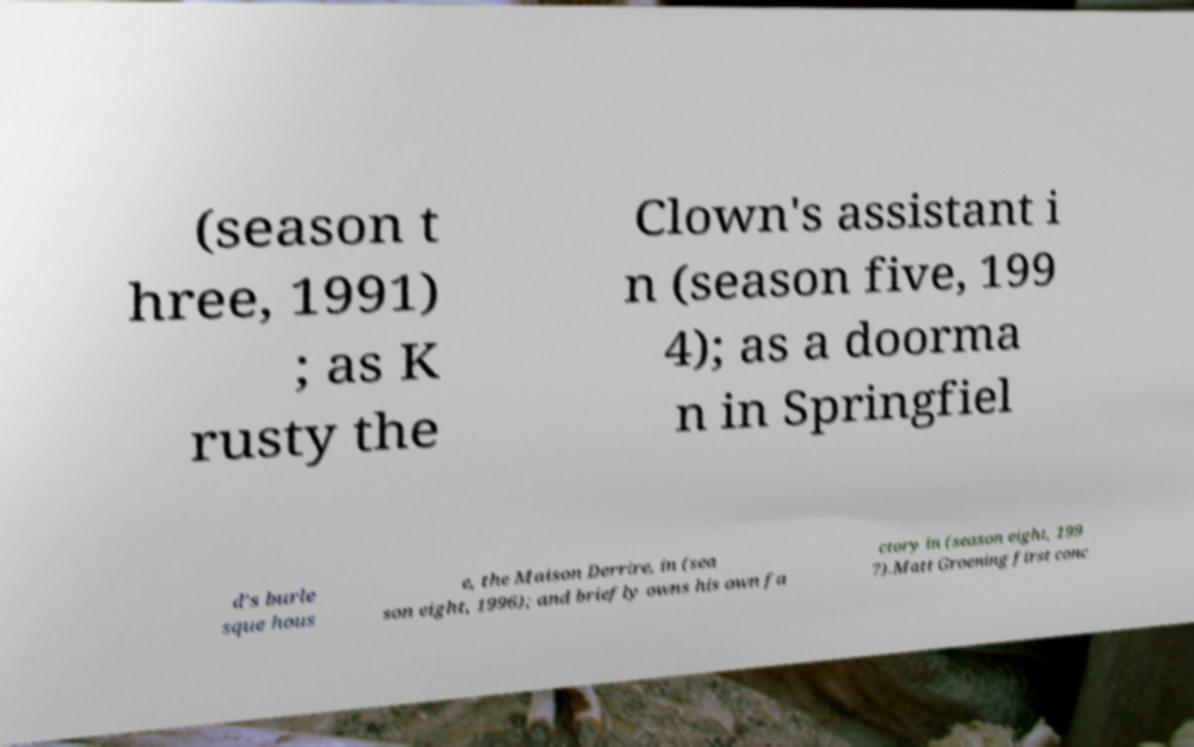Could you assist in decoding the text presented in this image and type it out clearly? (season t hree, 1991) ; as K rusty the Clown's assistant i n (season five, 199 4); as a doorma n in Springfiel d's burle sque hous e, the Maison Derrire, in (sea son eight, 1996); and briefly owns his own fa ctory in (season eight, 199 7).Matt Groening first conc 